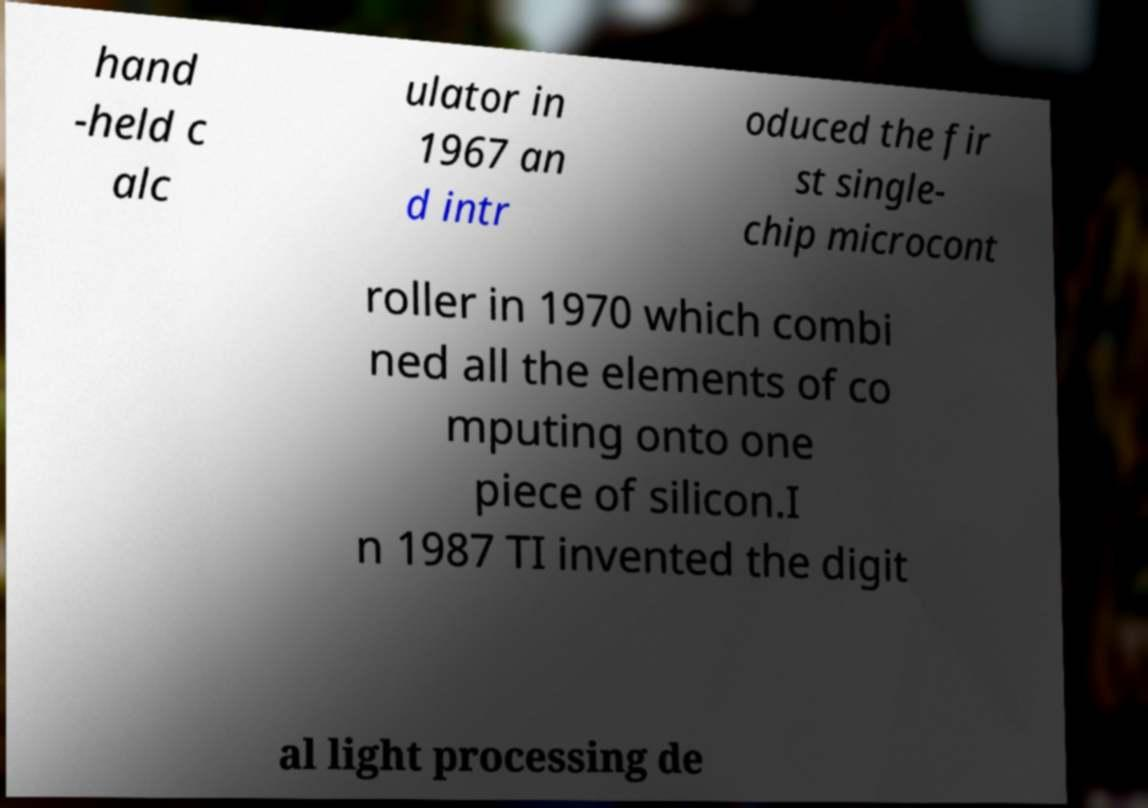For documentation purposes, I need the text within this image transcribed. Could you provide that? hand -held c alc ulator in 1967 an d intr oduced the fir st single- chip microcont roller in 1970 which combi ned all the elements of co mputing onto one piece of silicon.I n 1987 TI invented the digit al light processing de 